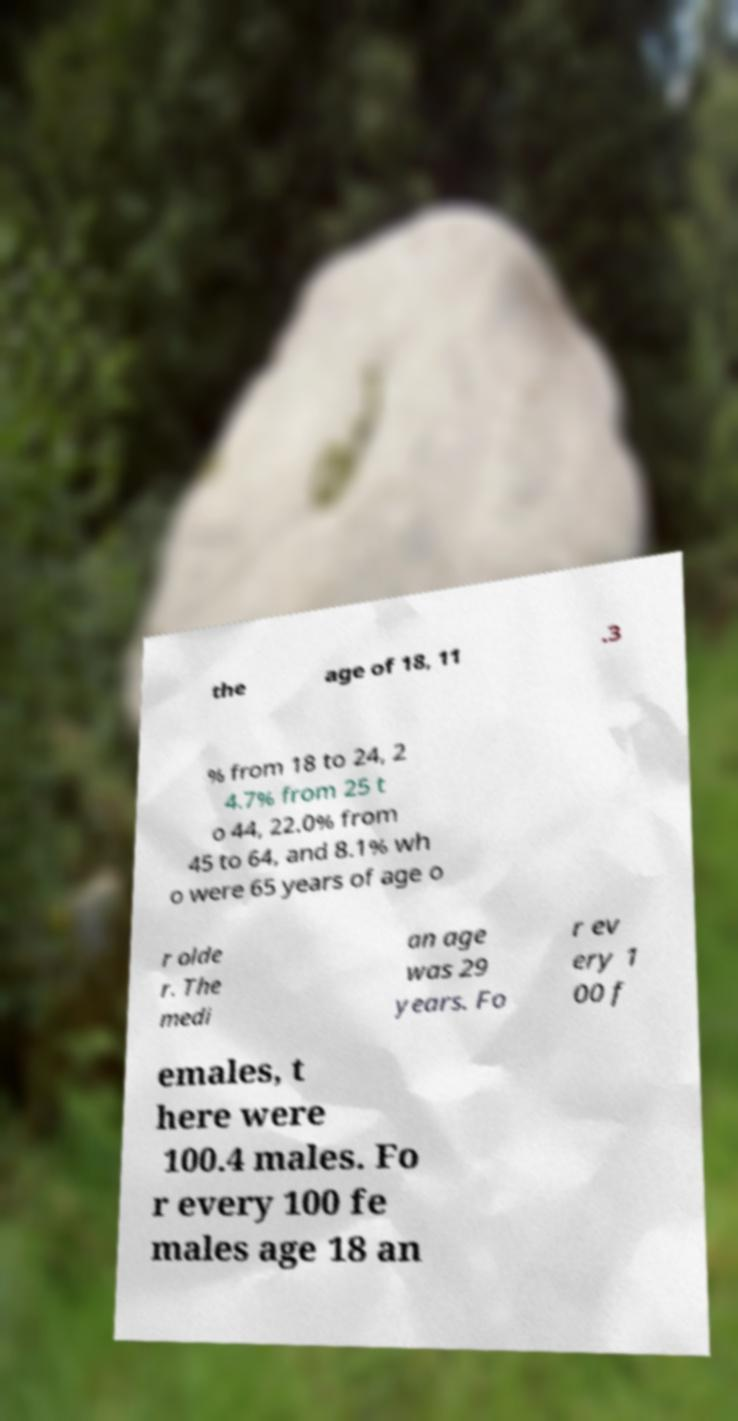For documentation purposes, I need the text within this image transcribed. Could you provide that? the age of 18, 11 .3 % from 18 to 24, 2 4.7% from 25 t o 44, 22.0% from 45 to 64, and 8.1% wh o were 65 years of age o r olde r. The medi an age was 29 years. Fo r ev ery 1 00 f emales, t here were 100.4 males. Fo r every 100 fe males age 18 an 